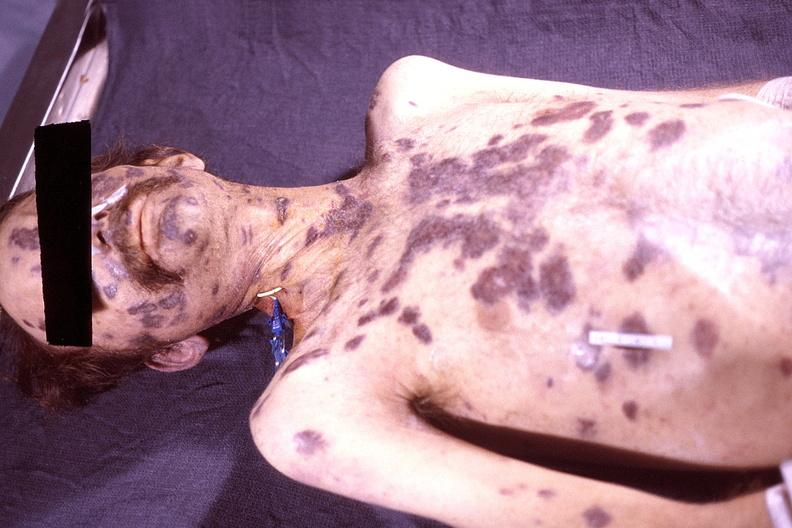does this image show skin, kaposis 's sarcoma?
Answer the question using a single word or phrase. Yes 